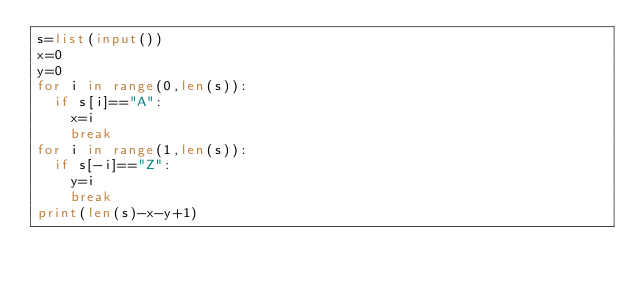Convert code to text. <code><loc_0><loc_0><loc_500><loc_500><_Python_>s=list(input())
x=0
y=0
for i in range(0,len(s)):
  if s[i]=="A":
    x=i
    break
for i in range(1,len(s)):
  if s[-i]=="Z":
    y=i
    break
print(len(s)-x-y+1)
    
</code> 